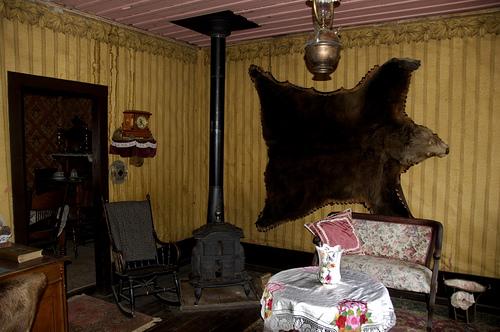Is there a heat source in the room?
Give a very brief answer. Yes. What type of skin is on the wall?
Give a very brief answer. Bear. Is there a vase on the table?
Be succinct. Yes. 